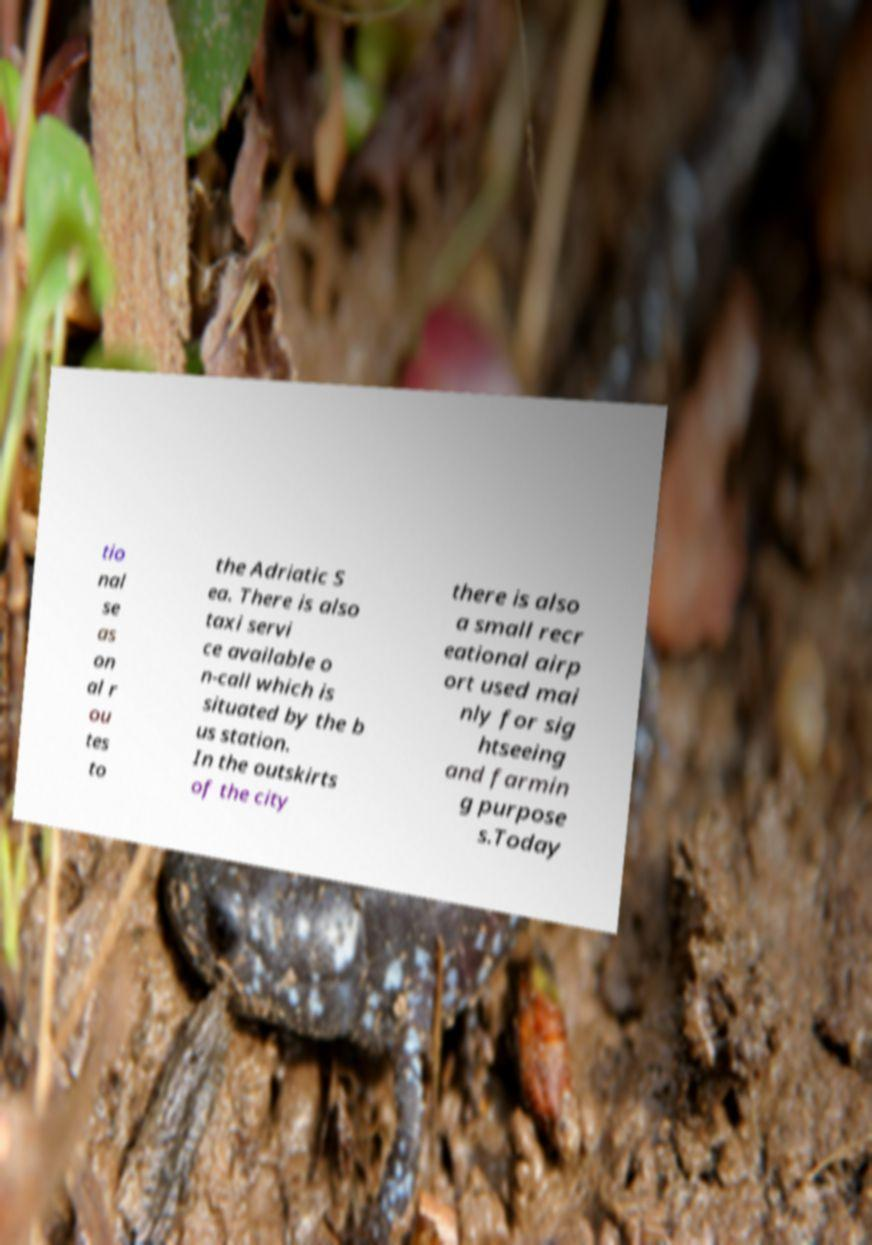For documentation purposes, I need the text within this image transcribed. Could you provide that? tio nal se as on al r ou tes to the Adriatic S ea. There is also taxi servi ce available o n-call which is situated by the b us station. In the outskirts of the city there is also a small recr eational airp ort used mai nly for sig htseeing and farmin g purpose s.Today 